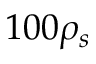<formula> <loc_0><loc_0><loc_500><loc_500>1 0 0 \rho _ { s }</formula> 